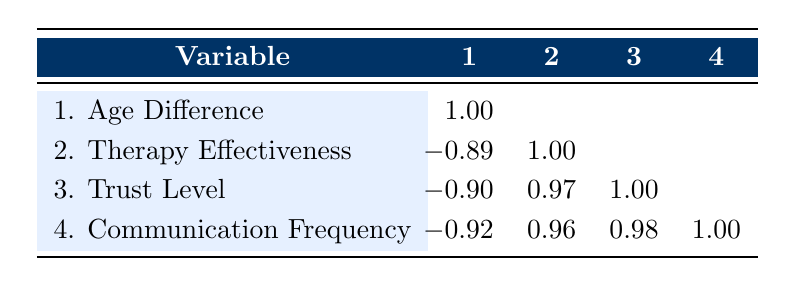What is the correlation between age difference and therapy effectiveness? The correlation value between age difference and therapy effectiveness is -0.89, indicating a strong negative relationship; as age difference increases, therapy effectiveness tends to decrease.
Answer: -0.89 Which variable has the highest positive correlation with trust level? The trust level has the highest positive correlation with communication frequency at 0.98, indicating that as communication frequency increases, trust level also tends to increase.
Answer: 0.98 Is there a positive correlation between therapy effectiveness and trust level? Yes, the correlation between therapy effectiveness and trust level is 0.97, indicating a strong positive relationship; higher therapy effectiveness is associated with higher trust levels.
Answer: Yes How does the correlation between age difference and communication frequency compare to that of trust level? The correlation between age difference and communication frequency is -0.92, which is more negative than the correlation between age difference and trust level, which is -0.90. This means that communication frequency is more strongly negatively correlated with age difference compared to trust level.
Answer: More negative What is the average correlation between therapy effectiveness, trust level, and communication frequency? To find the average, we sum the correlations: 0.97 (trust level and therapy effectiveness) + 0.96 (communication frequency and therapy effectiveness) + 0.98 (communication frequency and trust level) = 2.91. Dividing by 3 gives an average of 0.97.
Answer: 0.97 What can be inferred about the relationship between trust level and age difference? The correlation between trust level and age difference is -0.90, suggesting that as the age difference increases, the trust level tends to decrease.
Answer: Trust level decreases with age difference Are the correlations between communication frequency and both therapy effectiveness and trust level consistent? Yes, the correlations are consistent; both are positive, 0.96 with therapy effectiveness and 0.98 with trust level, suggesting that improvements in communication frequency are associated with improvements in both variables.
Answer: Yes What is the relationship trend between age difference and the effectiveness of therapy for sibling pairs with an age difference of 1 year? For sibling pairs with an age difference of 1 year (James & Michael and Liam & Emma), both showed high therapy effectiveness scores of 9 and 10, indicating that smaller age differences may be associated with higher therapy effectiveness.
Answer: Higher effectiveness with smaller age difference 